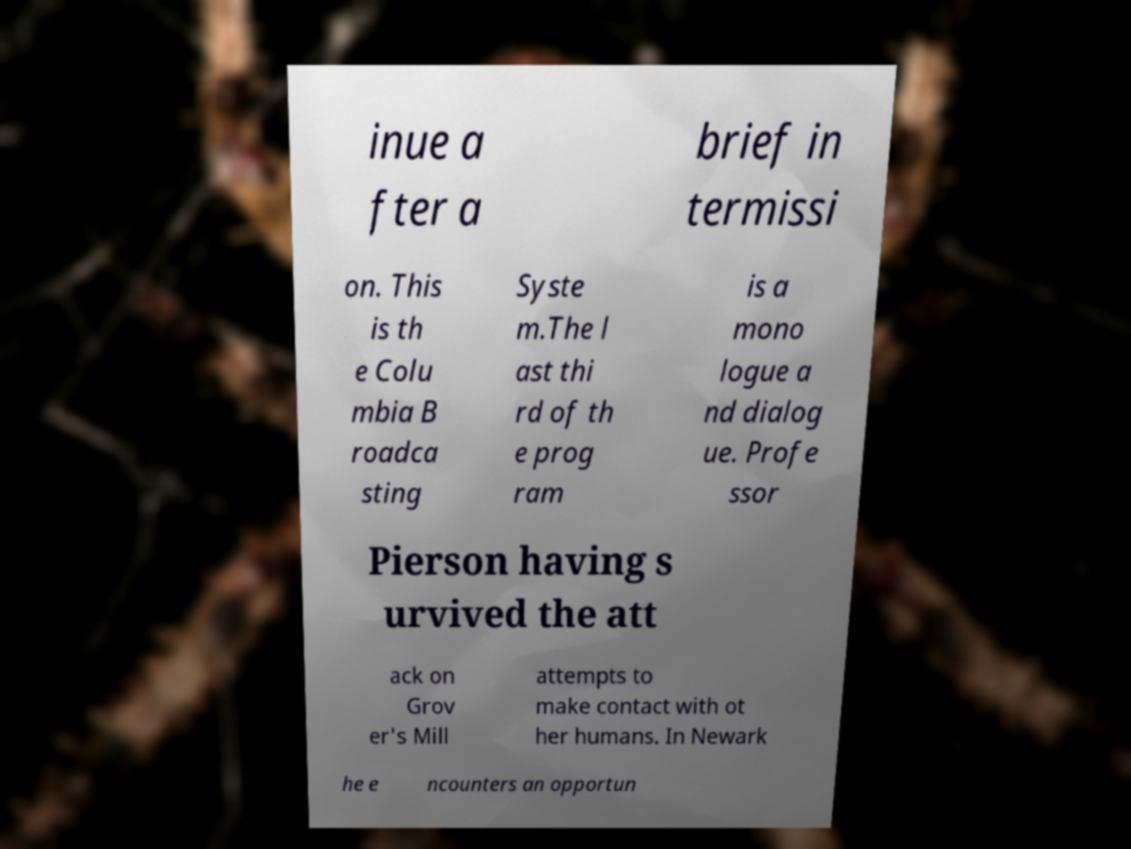Can you accurately transcribe the text from the provided image for me? inue a fter a brief in termissi on. This is th e Colu mbia B roadca sting Syste m.The l ast thi rd of th e prog ram is a mono logue a nd dialog ue. Profe ssor Pierson having s urvived the att ack on Grov er's Mill attempts to make contact with ot her humans. In Newark he e ncounters an opportun 